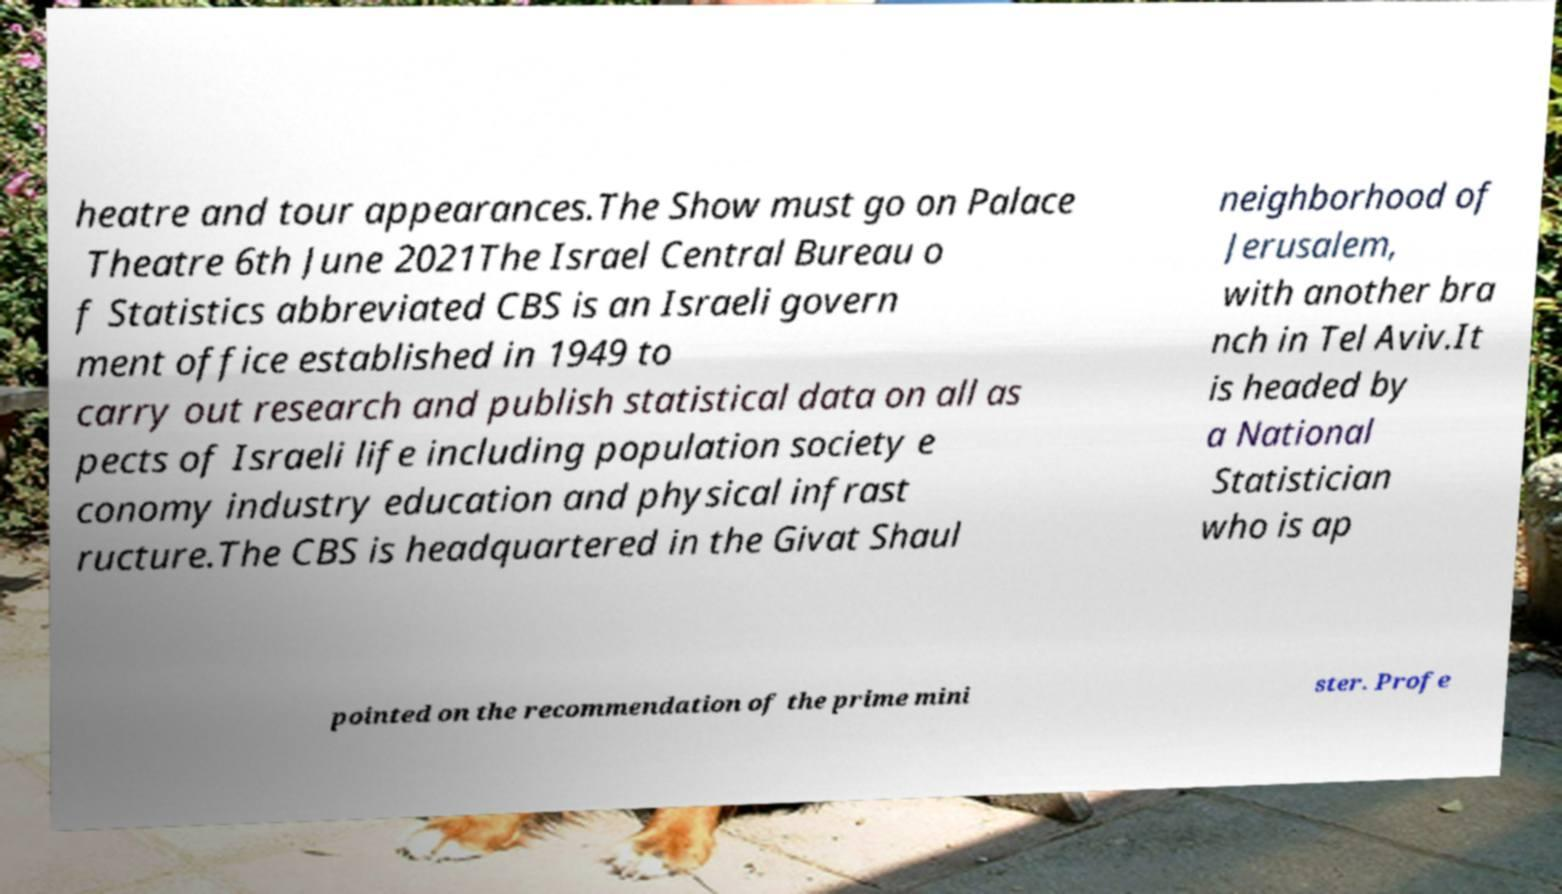Can you read and provide the text displayed in the image?This photo seems to have some interesting text. Can you extract and type it out for me? heatre and tour appearances.The Show must go on Palace Theatre 6th June 2021The Israel Central Bureau o f Statistics abbreviated CBS is an Israeli govern ment office established in 1949 to carry out research and publish statistical data on all as pects of Israeli life including population society e conomy industry education and physical infrast ructure.The CBS is headquartered in the Givat Shaul neighborhood of Jerusalem, with another bra nch in Tel Aviv.It is headed by a National Statistician who is ap pointed on the recommendation of the prime mini ster. Profe 